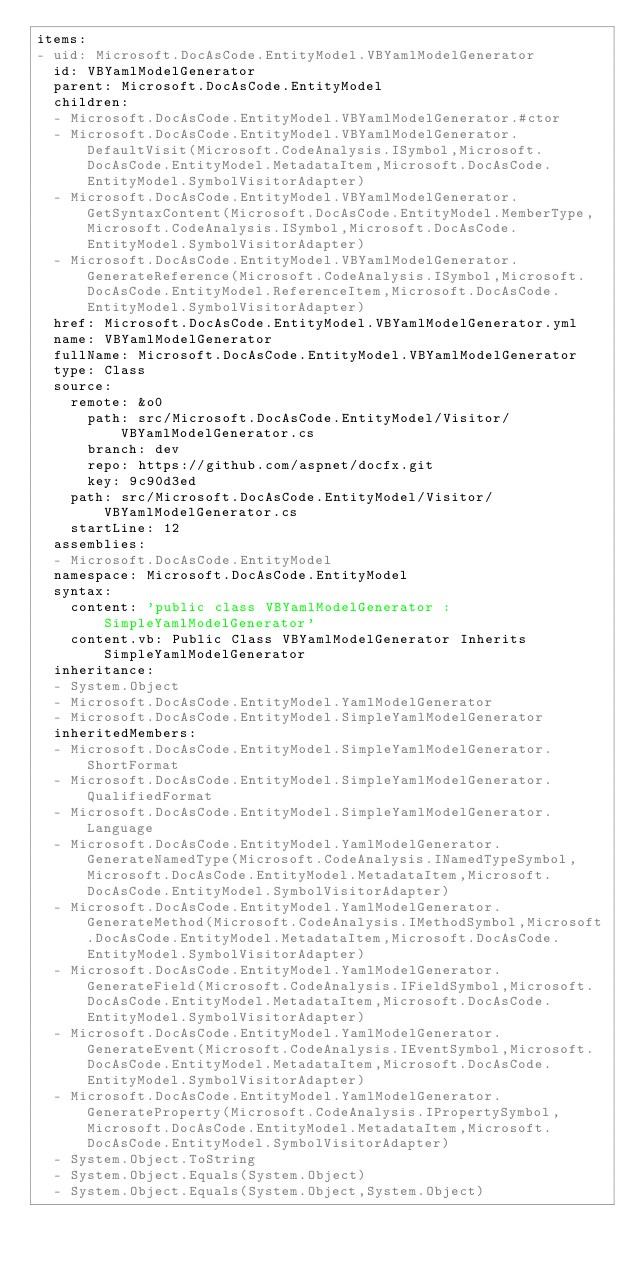<code> <loc_0><loc_0><loc_500><loc_500><_YAML_>items:
- uid: Microsoft.DocAsCode.EntityModel.VBYamlModelGenerator
  id: VBYamlModelGenerator
  parent: Microsoft.DocAsCode.EntityModel
  children:
  - Microsoft.DocAsCode.EntityModel.VBYamlModelGenerator.#ctor
  - Microsoft.DocAsCode.EntityModel.VBYamlModelGenerator.DefaultVisit(Microsoft.CodeAnalysis.ISymbol,Microsoft.DocAsCode.EntityModel.MetadataItem,Microsoft.DocAsCode.EntityModel.SymbolVisitorAdapter)
  - Microsoft.DocAsCode.EntityModel.VBYamlModelGenerator.GetSyntaxContent(Microsoft.DocAsCode.EntityModel.MemberType,Microsoft.CodeAnalysis.ISymbol,Microsoft.DocAsCode.EntityModel.SymbolVisitorAdapter)
  - Microsoft.DocAsCode.EntityModel.VBYamlModelGenerator.GenerateReference(Microsoft.CodeAnalysis.ISymbol,Microsoft.DocAsCode.EntityModel.ReferenceItem,Microsoft.DocAsCode.EntityModel.SymbolVisitorAdapter)
  href: Microsoft.DocAsCode.EntityModel.VBYamlModelGenerator.yml
  name: VBYamlModelGenerator
  fullName: Microsoft.DocAsCode.EntityModel.VBYamlModelGenerator
  type: Class
  source:
    remote: &o0
      path: src/Microsoft.DocAsCode.EntityModel/Visitor/VBYamlModelGenerator.cs
      branch: dev
      repo: https://github.com/aspnet/docfx.git
      key: 9c90d3ed
    path: src/Microsoft.DocAsCode.EntityModel/Visitor/VBYamlModelGenerator.cs
    startLine: 12
  assemblies:
  - Microsoft.DocAsCode.EntityModel
  namespace: Microsoft.DocAsCode.EntityModel
  syntax:
    content: 'public class VBYamlModelGenerator : SimpleYamlModelGenerator'
    content.vb: Public Class VBYamlModelGenerator Inherits SimpleYamlModelGenerator
  inheritance:
  - System.Object
  - Microsoft.DocAsCode.EntityModel.YamlModelGenerator
  - Microsoft.DocAsCode.EntityModel.SimpleYamlModelGenerator
  inheritedMembers:
  - Microsoft.DocAsCode.EntityModel.SimpleYamlModelGenerator.ShortFormat
  - Microsoft.DocAsCode.EntityModel.SimpleYamlModelGenerator.QualifiedFormat
  - Microsoft.DocAsCode.EntityModel.SimpleYamlModelGenerator.Language
  - Microsoft.DocAsCode.EntityModel.YamlModelGenerator.GenerateNamedType(Microsoft.CodeAnalysis.INamedTypeSymbol,Microsoft.DocAsCode.EntityModel.MetadataItem,Microsoft.DocAsCode.EntityModel.SymbolVisitorAdapter)
  - Microsoft.DocAsCode.EntityModel.YamlModelGenerator.GenerateMethod(Microsoft.CodeAnalysis.IMethodSymbol,Microsoft.DocAsCode.EntityModel.MetadataItem,Microsoft.DocAsCode.EntityModel.SymbolVisitorAdapter)
  - Microsoft.DocAsCode.EntityModel.YamlModelGenerator.GenerateField(Microsoft.CodeAnalysis.IFieldSymbol,Microsoft.DocAsCode.EntityModel.MetadataItem,Microsoft.DocAsCode.EntityModel.SymbolVisitorAdapter)
  - Microsoft.DocAsCode.EntityModel.YamlModelGenerator.GenerateEvent(Microsoft.CodeAnalysis.IEventSymbol,Microsoft.DocAsCode.EntityModel.MetadataItem,Microsoft.DocAsCode.EntityModel.SymbolVisitorAdapter)
  - Microsoft.DocAsCode.EntityModel.YamlModelGenerator.GenerateProperty(Microsoft.CodeAnalysis.IPropertySymbol,Microsoft.DocAsCode.EntityModel.MetadataItem,Microsoft.DocAsCode.EntityModel.SymbolVisitorAdapter)
  - System.Object.ToString
  - System.Object.Equals(System.Object)
  - System.Object.Equals(System.Object,System.Object)</code> 